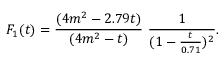Convert formula to latex. <formula><loc_0><loc_0><loc_500><loc_500>F _ { 1 } ( t ) = \frac { ( 4 m ^ { 2 } - 2 . 7 9 t ) } { ( 4 m ^ { 2 } - t ) } \ \frac { 1 } { ( 1 - \frac { t } { 0 . 7 1 } ) ^ { 2 } } .</formula> 